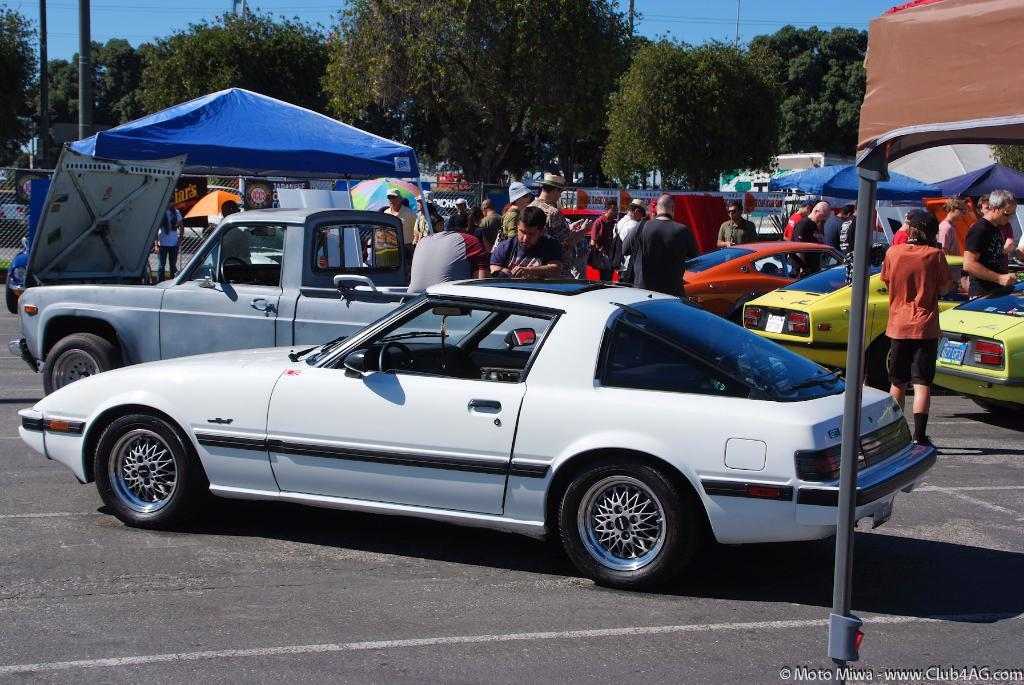Who or what can be seen in the image? There are people in the image. What else is present in the image besides people? There are vehicles on the road, tents, a fence, trees, poles, and the sky is visible in the background of the image. What type of vegetable is being harvested in the image? There is no vegetable being harvested in the image. The image features people, vehicles, tents, a fence, trees, poles, and the sky in the background. 